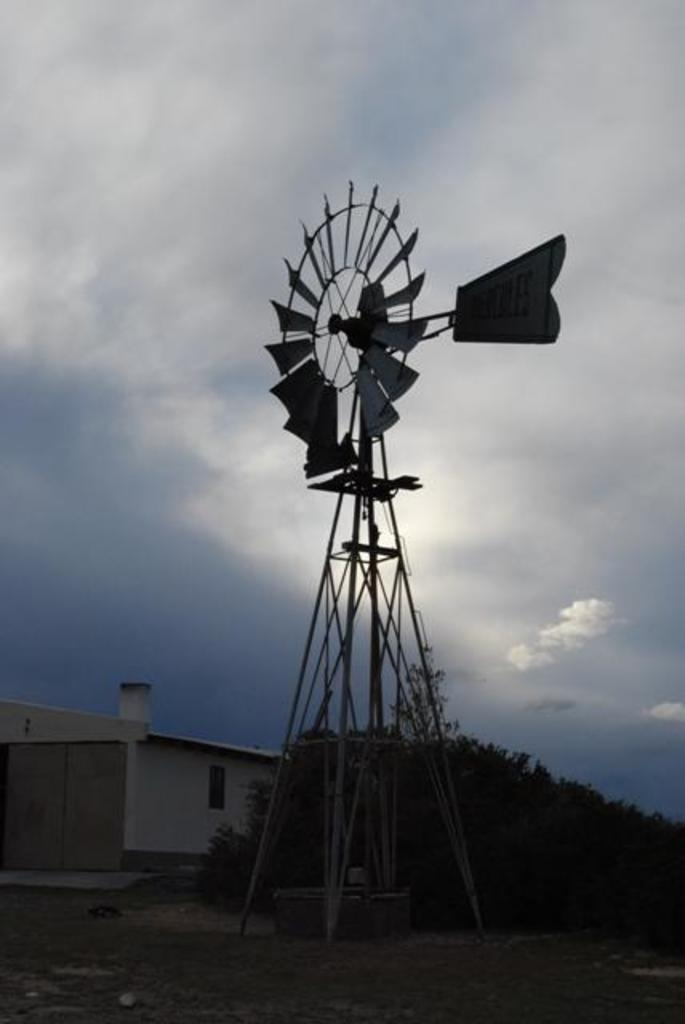What type of windmill is in the image? There is a water windmill in the image. What structure is located at the bottom of the image? There is a house at the bottom of the image. What type of vegetation is at the bottom of the image? There are trees at the bottom of the image. What is visible in the background of the image? The sky is visible in the background of the image. What type of jelly can be seen in the wilderness in the image? There is no jelly or wilderness present in the image. The image features a water windmill, a house, trees, and the sky. 